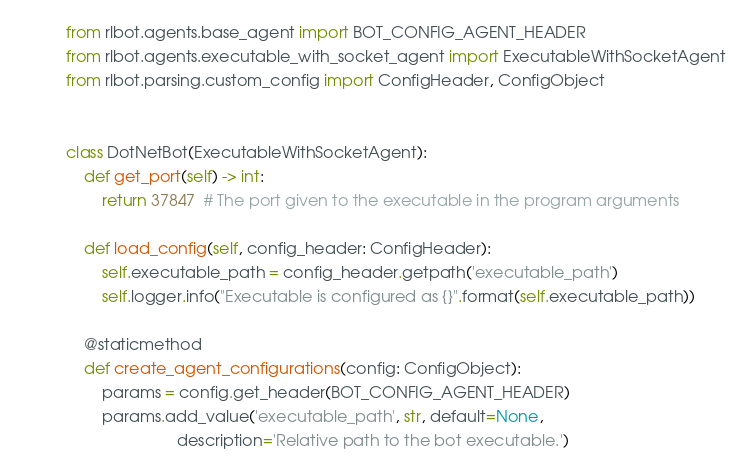<code> <loc_0><loc_0><loc_500><loc_500><_Python_>from rlbot.agents.base_agent import BOT_CONFIG_AGENT_HEADER
from rlbot.agents.executable_with_socket_agent import ExecutableWithSocketAgent
from rlbot.parsing.custom_config import ConfigHeader, ConfigObject


class DotNetBot(ExecutableWithSocketAgent):
    def get_port(self) -> int:
        return 37847  # The port given to the executable in the program arguments

    def load_config(self, config_header: ConfigHeader):
        self.executable_path = config_header.getpath('executable_path')
        self.logger.info("Executable is configured as {}".format(self.executable_path))

    @staticmethod
    def create_agent_configurations(config: ConfigObject):
        params = config.get_header(BOT_CONFIG_AGENT_HEADER)
        params.add_value('executable_path', str, default=None,
                         description='Relative path to the bot executable.')
</code> 